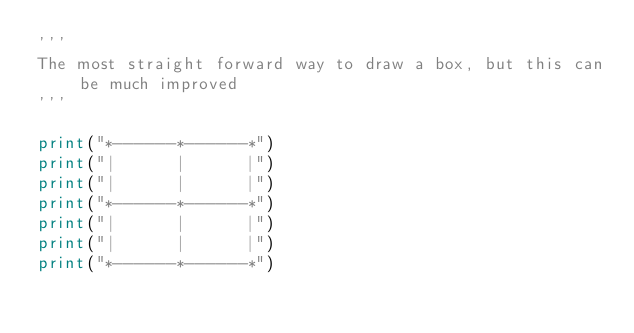<code> <loc_0><loc_0><loc_500><loc_500><_Python_>'''
The most straight forward way to draw a box, but this can be much improved
'''

print("*------*------*")
print("|      |      |")
print("|      |      |")
print("*------*------*")
print("|      |      |")
print("|      |      |")
print("*------*------*")</code> 